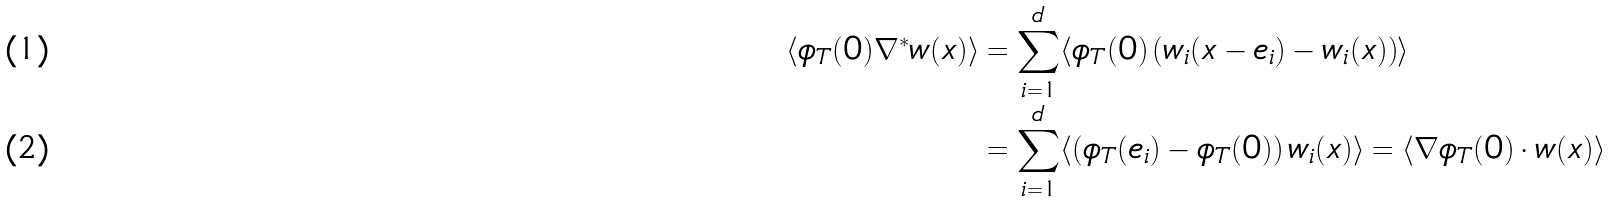<formula> <loc_0><loc_0><loc_500><loc_500>\langle \phi _ { T } ( 0 ) \nabla ^ { * } w ( x ) \rangle & = \sum _ { i = 1 } ^ { d } \langle \phi _ { T } ( 0 ) \left ( w _ { i } ( x - e _ { i } ) - w _ { i } ( x ) \right ) \rangle \\ & = \sum _ { i = 1 } ^ { d } \langle \left ( \phi _ { T } ( e _ { i } ) - \phi _ { T } ( 0 ) \right ) w _ { i } ( x ) \rangle = \langle \nabla \phi _ { T } ( 0 ) \cdot w ( x ) \rangle</formula> 